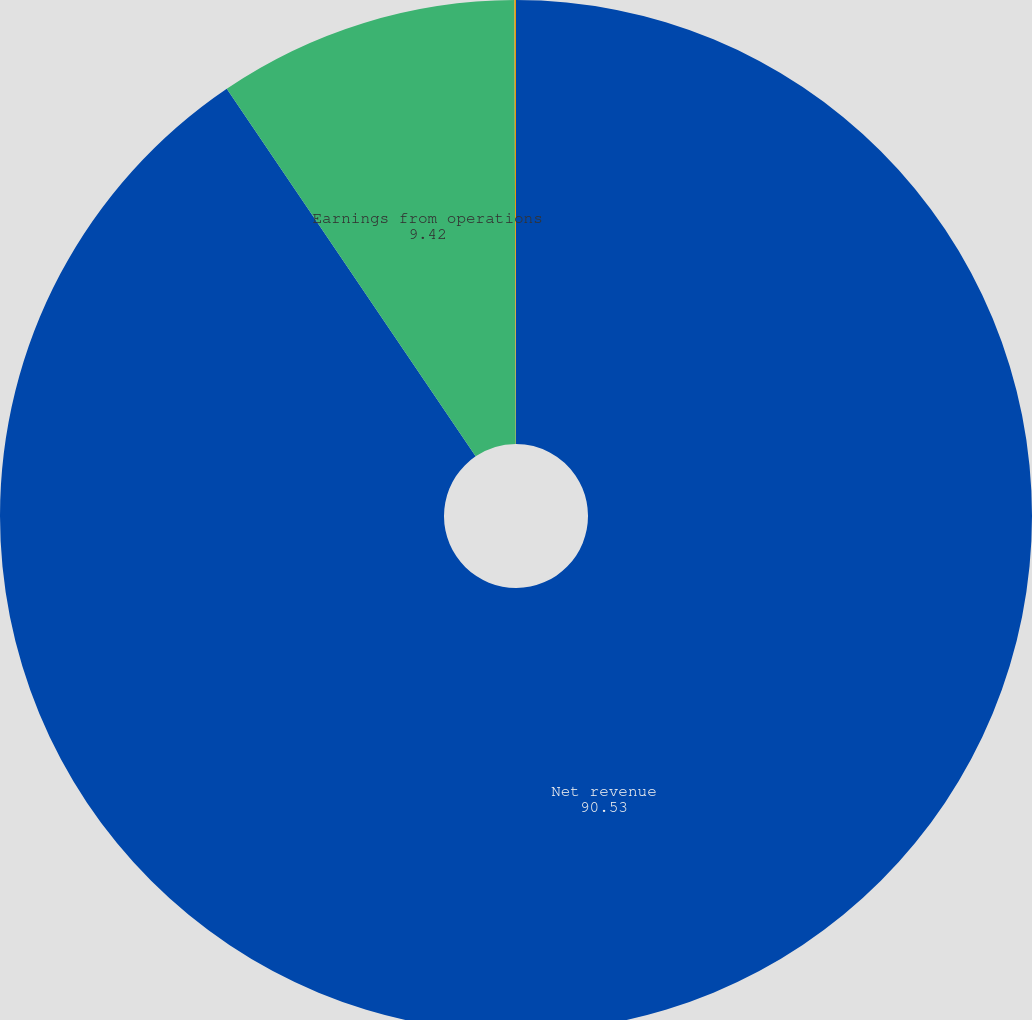<chart> <loc_0><loc_0><loc_500><loc_500><pie_chart><fcel>Net revenue<fcel>Earnings from operations<fcel>Earnings from operations as a<nl><fcel>90.53%<fcel>9.42%<fcel>0.05%<nl></chart> 